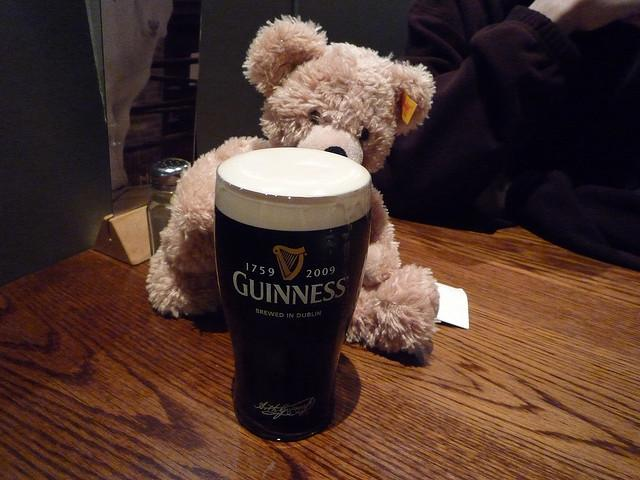What plant adds bitterness to this beverage? Please explain your reasoning. hops. Hops provide bitterness to beers, and guinness is a beer. 